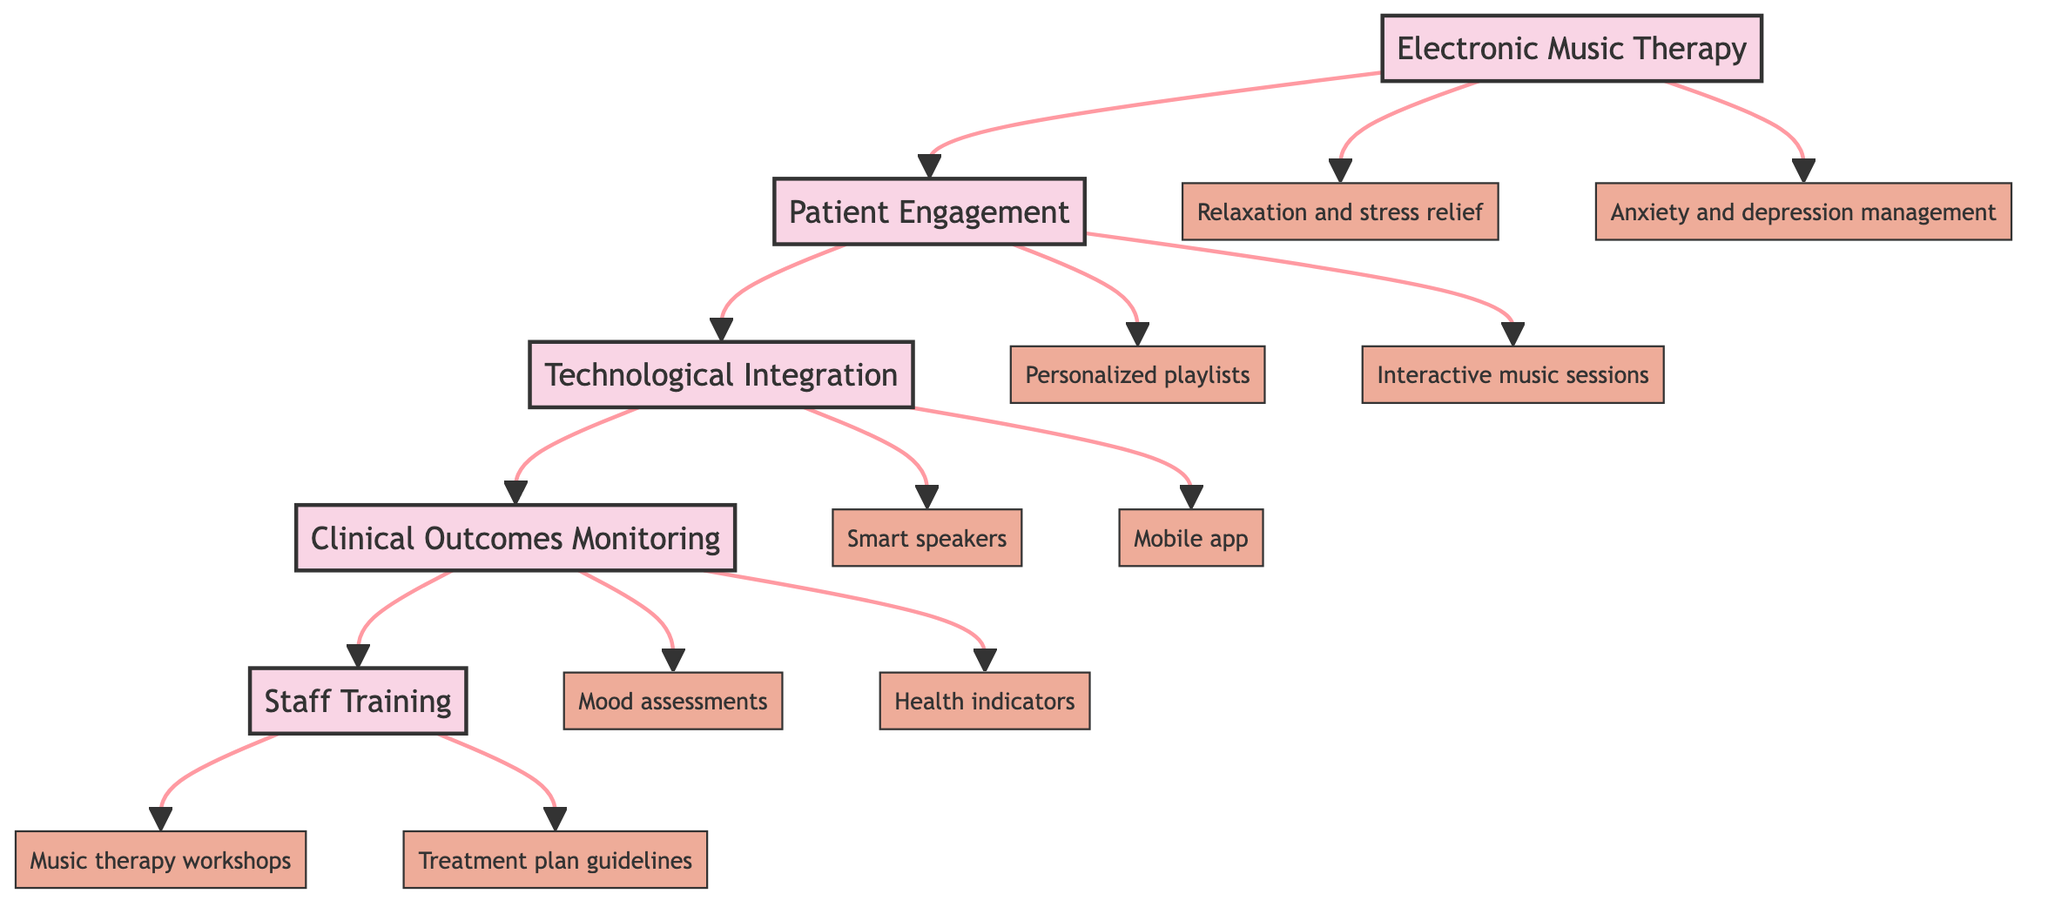What is the first component in the pathway? The first component in the pathway is represented as the starting node, which is "Electronic Music Therapy." By locating the topmost node in the diagram, we identify it as the entry point of the process.
Answer: Electronic Music Therapy How many details are associated with "Patient Engagement"? By reviewing the "Patient Engagement" node, there are two details listed: "Personalized playlists for mood enhancement" and "Interactive music sessions." Counting these details gives us the total.
Answer: 2 What follows "Technological Integration" in the pathway? The pathway indicates that "Clinical Outcomes Monitoring" directly follows "Technological Integration," as there is an arrow leading from the former to the latter.
Answer: Clinical Outcomes Monitoring How many components are there in total? The components in the diagram are "Electronic Music Therapy," "Patient Engagement," "Technological Integration," "Clinical Outcomes Monitoring," and "Staff Training." Counting all these components gives the total number.
Answer: 5 What are the two details under "Electronic Music Therapy"? Looking at the details associated with "Electronic Music Therapy," they are "Relaxation and stress relief" and "Anxiety and depression management." These two details are directly connected to the main component.
Answer: Relaxation and stress relief, Anxiety and depression management What does the arrow from "Clinical Outcomes Monitoring" point to? The arrow from "Clinical Outcomes Monitoring" points to "Staff Training," indicating that after monitoring clinical outcomes, the process leads to training staff. This shows the flow of the pathway.
Answer: Staff Training Which component includes a mobile app? The "Technological Integration" component includes the detail of a "Mobile app for music selection and customization." This can be identified by looking at the details connected to this specific component.
Answer: Technological Integration Which part of the pathway focuses on monitoring health indicators? The part that focuses on monitoring health indicators is "Clinical Outcomes Monitoring." This component is designated for tracking the effects of the integration of music on health.
Answer: Clinical Outcomes Monitoring 